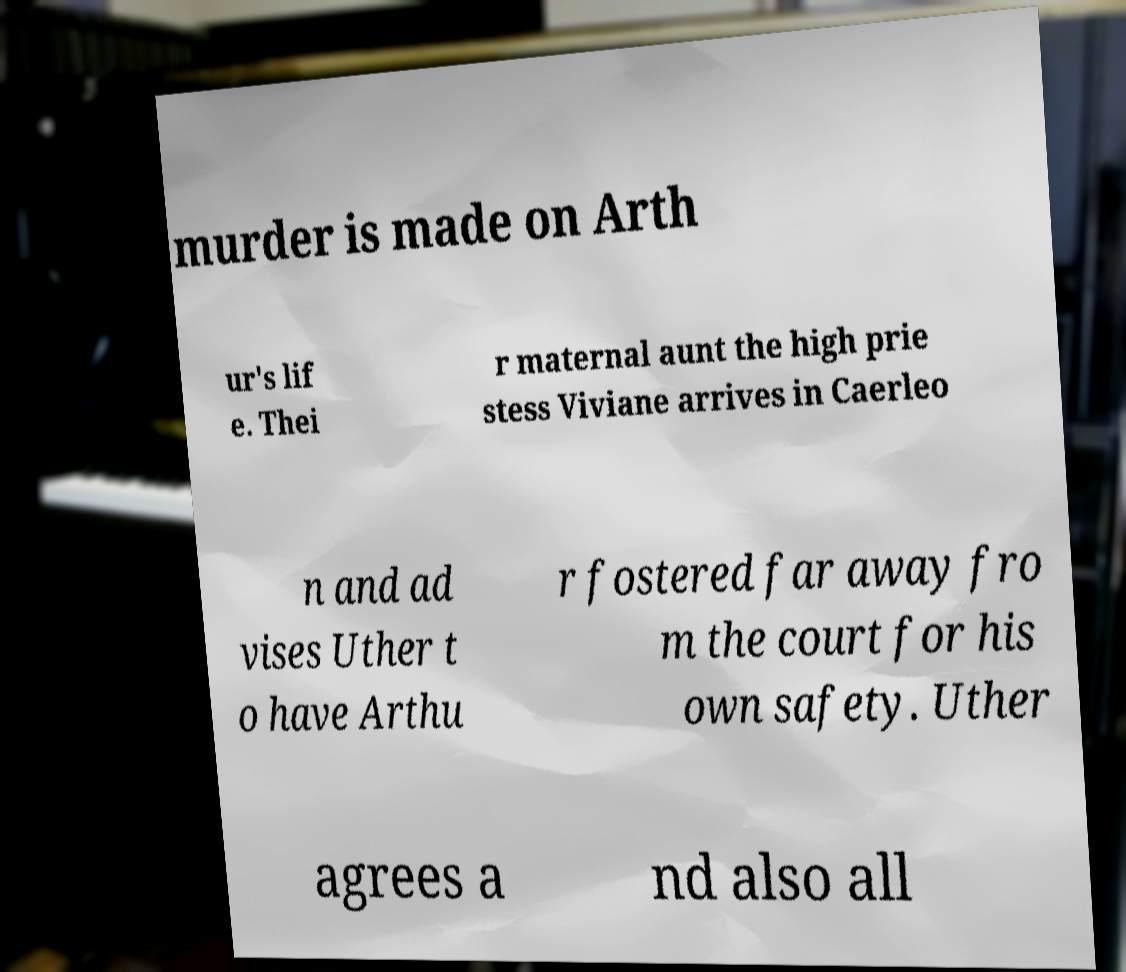Please read and relay the text visible in this image. What does it say? murder is made on Arth ur's lif e. Thei r maternal aunt the high prie stess Viviane arrives in Caerleo n and ad vises Uther t o have Arthu r fostered far away fro m the court for his own safety. Uther agrees a nd also all 